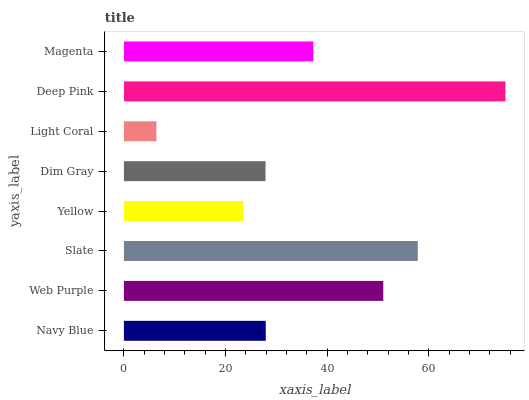Is Light Coral the minimum?
Answer yes or no. Yes. Is Deep Pink the maximum?
Answer yes or no. Yes. Is Web Purple the minimum?
Answer yes or no. No. Is Web Purple the maximum?
Answer yes or no. No. Is Web Purple greater than Navy Blue?
Answer yes or no. Yes. Is Navy Blue less than Web Purple?
Answer yes or no. Yes. Is Navy Blue greater than Web Purple?
Answer yes or no. No. Is Web Purple less than Navy Blue?
Answer yes or no. No. Is Magenta the high median?
Answer yes or no. Yes. Is Navy Blue the low median?
Answer yes or no. Yes. Is Yellow the high median?
Answer yes or no. No. Is Slate the low median?
Answer yes or no. No. 